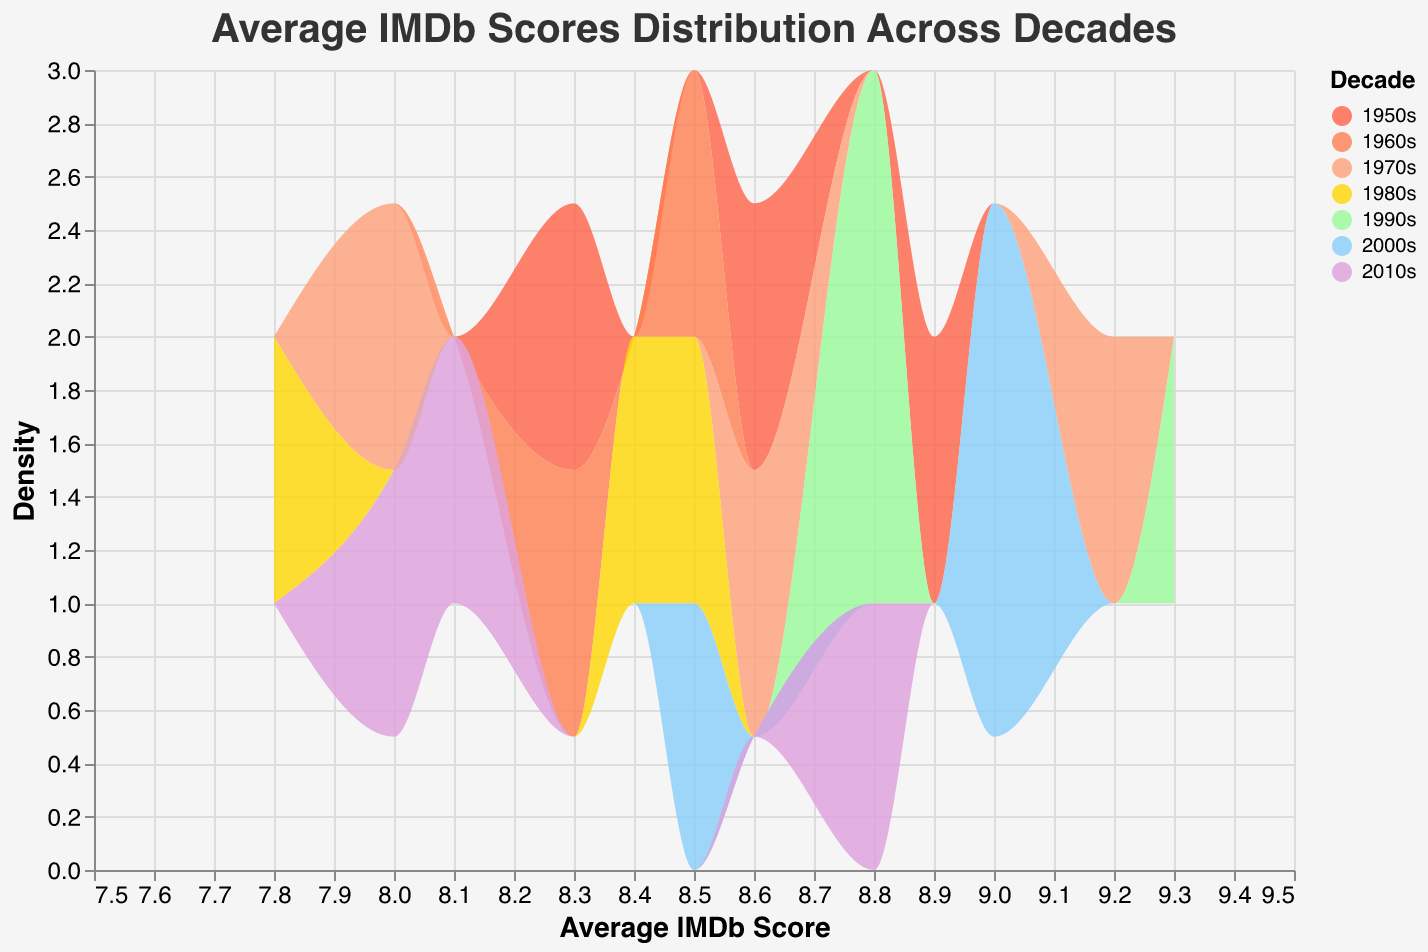What is the title of the density plot? The title of the graph is located at the top and usually provides a summary of what the graph represents. Here, the title reads "Average IMDb Scores Distribution Across Decades."
Answer: Average IMDb Scores Distribution Across Decades Which decade has the highest peak in the density plot? To identify which decade has the highest peak, look for the tallest section of the density plot. This represents the decade with the highest density of IMDb scores.
Answer: 1990s What is the range of the x-axis? The x-axis represents the Average IMDb Score, and from the plot, the values range from 7.5 to 9.5.
Answer: 7.5 to 9.5 Which decade appears to have movies with the most varied IMDb scores? To determine which decade has the most varied IMDb scores, look for the decade that spans the largest range along the x-axis. The 1970s and 1980s seem to have a broad range of scores.
Answer: 1970s How does the 2010s density distribution compare to the 1950s? Compare the height and spread of the density plots for both the 2010s and 1950s. The 2010s have a wider spread and a lower peak compared to the 1950s, which has a narrower spread and a higher peak.
Answer: The 2010s have a wider spread and lower peak What is the most common IMDb score range for the 1980s based on the density plot? To identify the most common IMDb score range, look for the highest peak in the density for the 1980s. The 1980s exhibit their highest density around 8.4 to 8.5 IMDb scores.
Answer: 8.4 to 8.5 Which decade has the least varied IMDb scores? The decade with the narrowest density distribution along the x-axis shows the least variation in IMDb scores. The 1960s decade appears to have the most concentrated peak.
Answer: 1960s Is there any decade where the density plot overlaps with another decade significantly? Look for areas in the density plot where different decades' colored areas overlap. The density plots for the 2000s and 2010s overlap significantly around the 8.5 to 9.0 IMDb score range.
Answer: 2000s and 2010s How does the density of IMDb scores in the 2000s compare to the 1990s? Compare the density plot of the 2000s to the 1990s. The 1990s have a higher peak, indicating a higher density of scores around a central value, while the 2000s show a slightly broader spread with lower peaks.
Answer: 1990s have a higher density peak What colors are used to represent the 1970s and 1980s decades in the plot? Identify the colors associated with each decade by referring to the chart legend. The 1970s are represented by a light orange, and the 1980s are represented by a gold color.
Answer: light orange for the 1970s, gold for the 1980s 